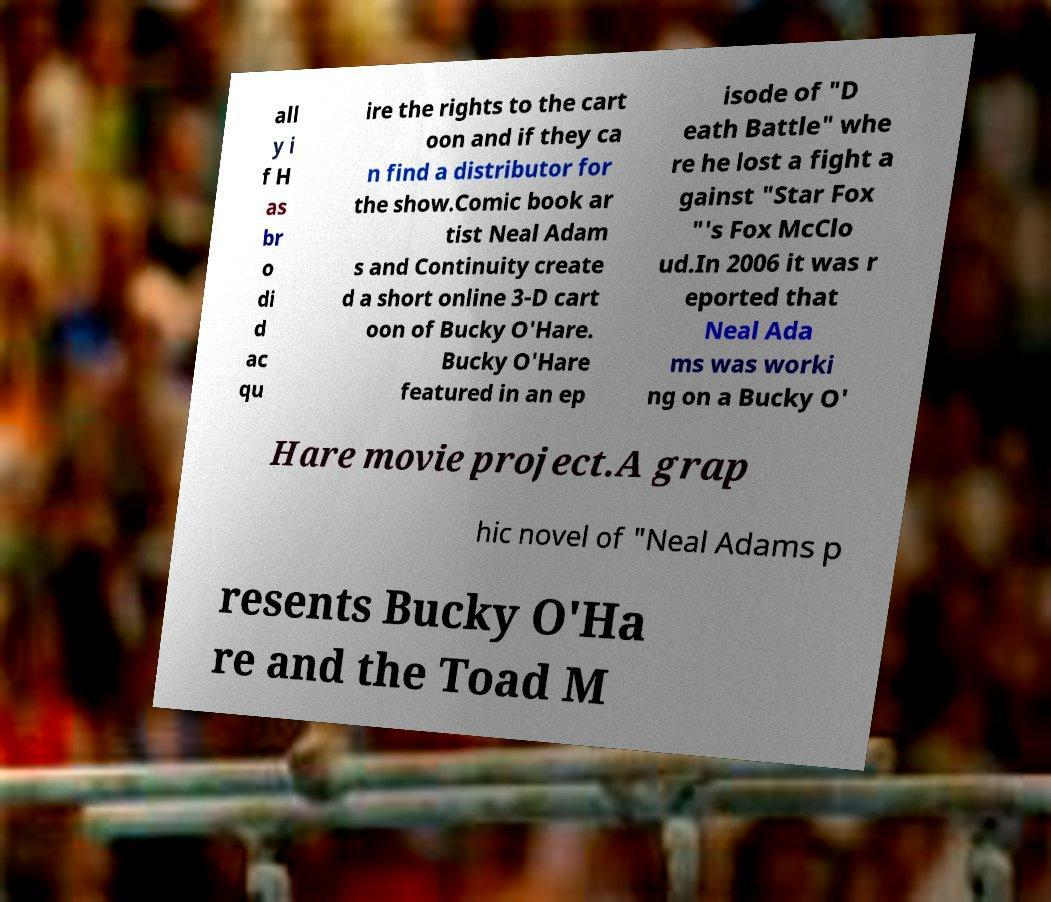What messages or text are displayed in this image? I need them in a readable, typed format. all y i f H as br o di d ac qu ire the rights to the cart oon and if they ca n find a distributor for the show.Comic book ar tist Neal Adam s and Continuity create d a short online 3-D cart oon of Bucky O'Hare. Bucky O'Hare featured in an ep isode of "D eath Battle" whe re he lost a fight a gainst "Star Fox "'s Fox McClo ud.In 2006 it was r eported that Neal Ada ms was worki ng on a Bucky O' Hare movie project.A grap hic novel of "Neal Adams p resents Bucky O'Ha re and the Toad M 